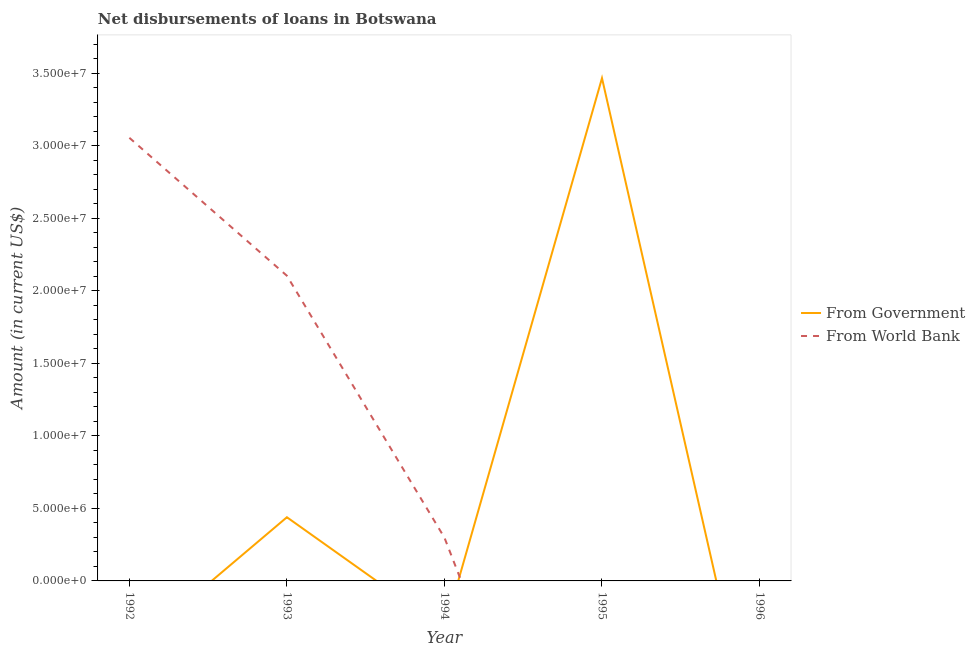Does the line corresponding to net disbursements of loan from world bank intersect with the line corresponding to net disbursements of loan from government?
Offer a terse response. Yes. Is the number of lines equal to the number of legend labels?
Provide a short and direct response. No. What is the net disbursements of loan from world bank in 1994?
Your answer should be very brief. 2.98e+06. Across all years, what is the maximum net disbursements of loan from government?
Provide a succinct answer. 3.47e+07. In which year was the net disbursements of loan from world bank maximum?
Offer a terse response. 1992. What is the total net disbursements of loan from government in the graph?
Make the answer very short. 3.91e+07. What is the difference between the net disbursements of loan from world bank in 1993 and that in 1994?
Your answer should be compact. 1.81e+07. What is the average net disbursements of loan from government per year?
Provide a short and direct response. 7.81e+06. In the year 1993, what is the difference between the net disbursements of loan from world bank and net disbursements of loan from government?
Offer a very short reply. 1.67e+07. In how many years, is the net disbursements of loan from world bank greater than 23000000 US$?
Provide a short and direct response. 1. What is the ratio of the net disbursements of loan from world bank in 1992 to that in 1994?
Offer a very short reply. 10.25. What is the difference between the highest and the second highest net disbursements of loan from world bank?
Give a very brief answer. 9.51e+06. What is the difference between the highest and the lowest net disbursements of loan from world bank?
Make the answer very short. 3.06e+07. In how many years, is the net disbursements of loan from world bank greater than the average net disbursements of loan from world bank taken over all years?
Provide a succinct answer. 2. Is the net disbursements of loan from government strictly greater than the net disbursements of loan from world bank over the years?
Make the answer very short. No. How many years are there in the graph?
Your answer should be compact. 5. What is the difference between two consecutive major ticks on the Y-axis?
Your answer should be compact. 5.00e+06. Are the values on the major ticks of Y-axis written in scientific E-notation?
Your answer should be very brief. Yes. Does the graph contain any zero values?
Your answer should be very brief. Yes. How many legend labels are there?
Offer a terse response. 2. How are the legend labels stacked?
Offer a very short reply. Vertical. What is the title of the graph?
Provide a short and direct response. Net disbursements of loans in Botswana. Does "UN agencies" appear as one of the legend labels in the graph?
Offer a very short reply. No. What is the label or title of the Y-axis?
Make the answer very short. Amount (in current US$). What is the Amount (in current US$) in From Government in 1992?
Your response must be concise. 0. What is the Amount (in current US$) of From World Bank in 1992?
Provide a succinct answer. 3.06e+07. What is the Amount (in current US$) in From Government in 1993?
Make the answer very short. 4.39e+06. What is the Amount (in current US$) in From World Bank in 1993?
Make the answer very short. 2.10e+07. What is the Amount (in current US$) in From World Bank in 1994?
Provide a succinct answer. 2.98e+06. What is the Amount (in current US$) of From Government in 1995?
Offer a terse response. 3.47e+07. What is the Amount (in current US$) of From World Bank in 1995?
Offer a very short reply. 0. What is the Amount (in current US$) in From Government in 1996?
Your answer should be compact. 0. Across all years, what is the maximum Amount (in current US$) of From Government?
Make the answer very short. 3.47e+07. Across all years, what is the maximum Amount (in current US$) in From World Bank?
Keep it short and to the point. 3.06e+07. Across all years, what is the minimum Amount (in current US$) of From Government?
Give a very brief answer. 0. Across all years, what is the minimum Amount (in current US$) in From World Bank?
Give a very brief answer. 0. What is the total Amount (in current US$) in From Government in the graph?
Your answer should be compact. 3.91e+07. What is the total Amount (in current US$) of From World Bank in the graph?
Provide a succinct answer. 5.46e+07. What is the difference between the Amount (in current US$) of From World Bank in 1992 and that in 1993?
Make the answer very short. 9.51e+06. What is the difference between the Amount (in current US$) in From World Bank in 1992 and that in 1994?
Your answer should be compact. 2.76e+07. What is the difference between the Amount (in current US$) of From World Bank in 1993 and that in 1994?
Give a very brief answer. 1.81e+07. What is the difference between the Amount (in current US$) in From Government in 1993 and that in 1995?
Your response must be concise. -3.03e+07. What is the difference between the Amount (in current US$) of From Government in 1993 and the Amount (in current US$) of From World Bank in 1994?
Keep it short and to the point. 1.41e+06. What is the average Amount (in current US$) of From Government per year?
Give a very brief answer. 7.81e+06. What is the average Amount (in current US$) in From World Bank per year?
Provide a succinct answer. 1.09e+07. In the year 1993, what is the difference between the Amount (in current US$) in From Government and Amount (in current US$) in From World Bank?
Ensure brevity in your answer.  -1.67e+07. What is the ratio of the Amount (in current US$) in From World Bank in 1992 to that in 1993?
Your response must be concise. 1.45. What is the ratio of the Amount (in current US$) in From World Bank in 1992 to that in 1994?
Give a very brief answer. 10.25. What is the ratio of the Amount (in current US$) of From World Bank in 1993 to that in 1994?
Your answer should be very brief. 7.06. What is the ratio of the Amount (in current US$) of From Government in 1993 to that in 1995?
Your answer should be very brief. 0.13. What is the difference between the highest and the second highest Amount (in current US$) in From World Bank?
Provide a succinct answer. 9.51e+06. What is the difference between the highest and the lowest Amount (in current US$) in From Government?
Offer a terse response. 3.47e+07. What is the difference between the highest and the lowest Amount (in current US$) of From World Bank?
Your response must be concise. 3.06e+07. 